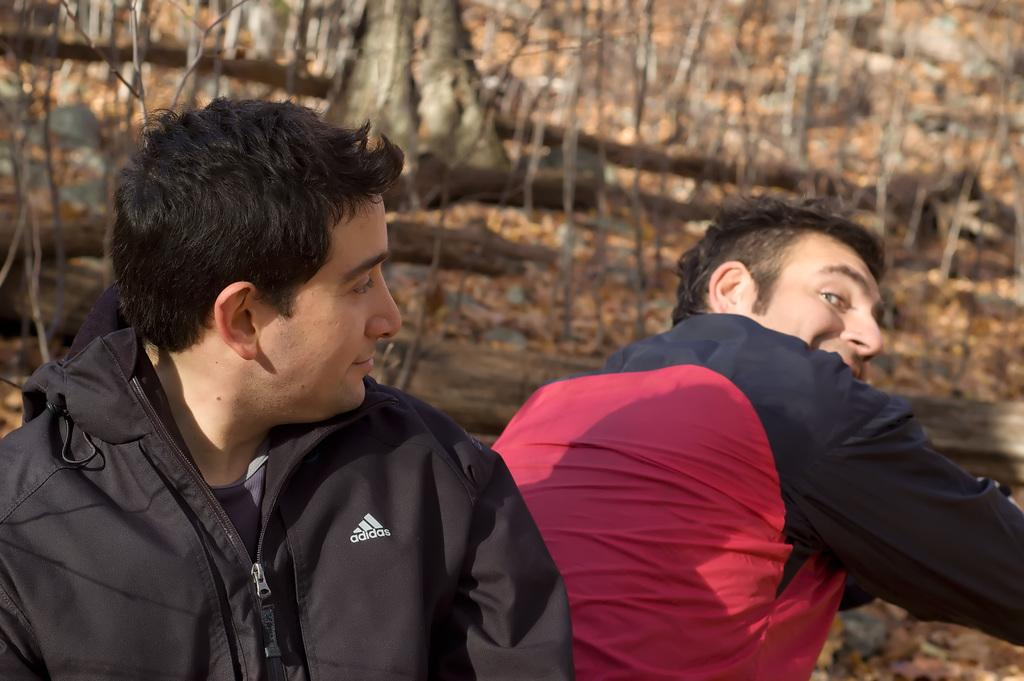What are the people in the image doing? The persons sitting in the image are smiling. What can be seen in the background of the image? There are trees in the background of the image. What is present on the ground in the image? Dry leaves are present on the ground. What type of horn can be heard in the image? There is no horn present in the image, and therefore no sound can be heard. 